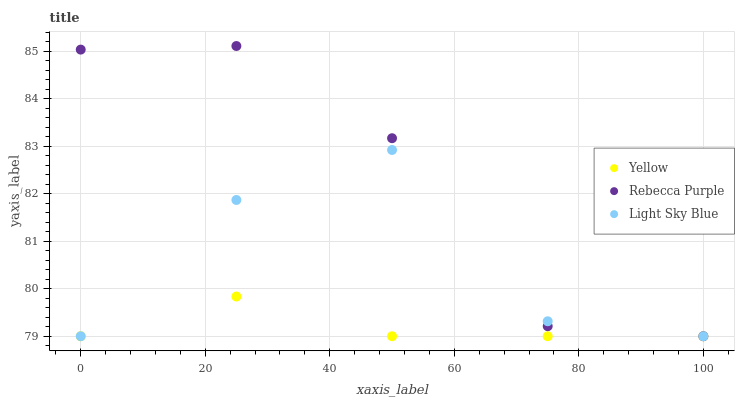Does Yellow have the minimum area under the curve?
Answer yes or no. Yes. Does Rebecca Purple have the maximum area under the curve?
Answer yes or no. Yes. Does Rebecca Purple have the minimum area under the curve?
Answer yes or no. No. Does Yellow have the maximum area under the curve?
Answer yes or no. No. Is Yellow the smoothest?
Answer yes or no. Yes. Is Light Sky Blue the roughest?
Answer yes or no. Yes. Is Rebecca Purple the smoothest?
Answer yes or no. No. Is Rebecca Purple the roughest?
Answer yes or no. No. Does Light Sky Blue have the lowest value?
Answer yes or no. Yes. Does Rebecca Purple have the highest value?
Answer yes or no. Yes. Does Yellow have the highest value?
Answer yes or no. No. Does Light Sky Blue intersect Yellow?
Answer yes or no. Yes. Is Light Sky Blue less than Yellow?
Answer yes or no. No. Is Light Sky Blue greater than Yellow?
Answer yes or no. No. 